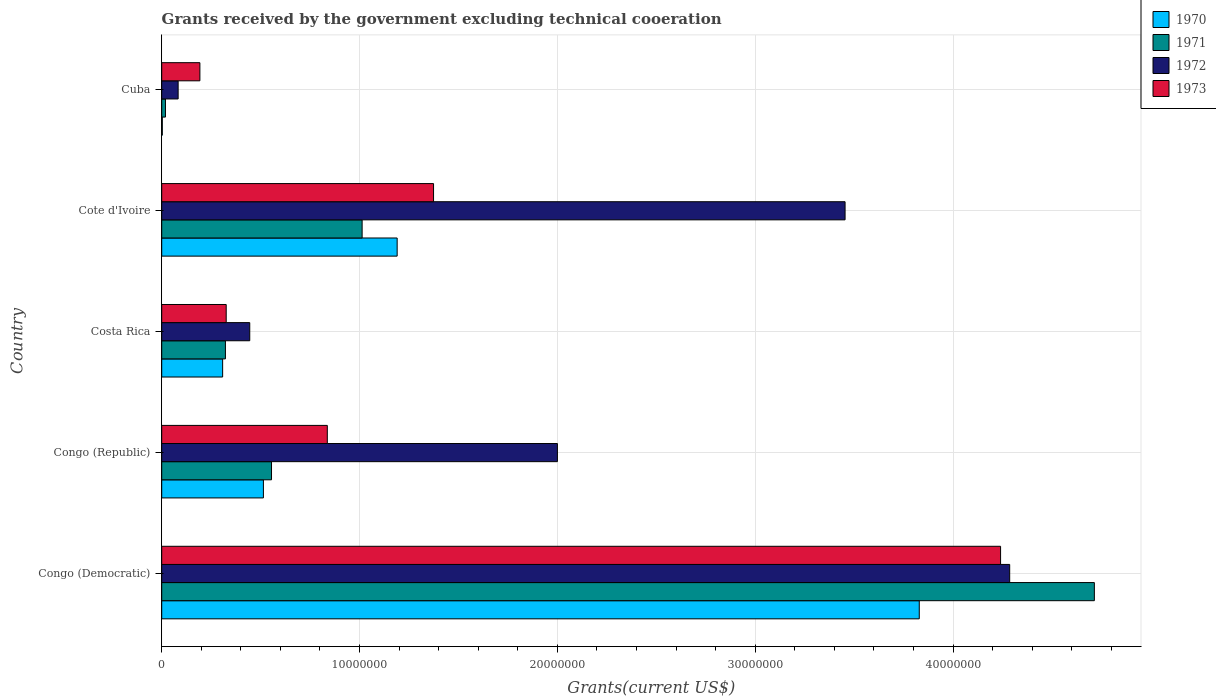How many different coloured bars are there?
Your answer should be very brief. 4. How many groups of bars are there?
Offer a very short reply. 5. How many bars are there on the 1st tick from the top?
Ensure brevity in your answer.  4. How many bars are there on the 3rd tick from the bottom?
Offer a very short reply. 4. What is the label of the 4th group of bars from the top?
Offer a very short reply. Congo (Republic). What is the total grants received by the government in 1972 in Costa Rica?
Keep it short and to the point. 4.45e+06. Across all countries, what is the maximum total grants received by the government in 1971?
Your answer should be very brief. 4.71e+07. In which country was the total grants received by the government in 1972 maximum?
Give a very brief answer. Congo (Democratic). In which country was the total grants received by the government in 1973 minimum?
Your answer should be very brief. Cuba. What is the total total grants received by the government in 1972 in the graph?
Give a very brief answer. 1.03e+08. What is the difference between the total grants received by the government in 1973 in Cote d'Ivoire and that in Cuba?
Offer a terse response. 1.18e+07. What is the difference between the total grants received by the government in 1970 in Congo (Republic) and the total grants received by the government in 1972 in Cuba?
Provide a succinct answer. 4.31e+06. What is the average total grants received by the government in 1971 per country?
Ensure brevity in your answer.  1.32e+07. What is the difference between the total grants received by the government in 1973 and total grants received by the government in 1971 in Congo (Democratic)?
Provide a short and direct response. -4.74e+06. What is the ratio of the total grants received by the government in 1973 in Congo (Democratic) to that in Congo (Republic)?
Your answer should be compact. 5.07. Is the difference between the total grants received by the government in 1973 in Costa Rica and Cote d'Ivoire greater than the difference between the total grants received by the government in 1971 in Costa Rica and Cote d'Ivoire?
Your answer should be very brief. No. What is the difference between the highest and the second highest total grants received by the government in 1973?
Give a very brief answer. 2.87e+07. What is the difference between the highest and the lowest total grants received by the government in 1970?
Ensure brevity in your answer.  3.83e+07. In how many countries, is the total grants received by the government in 1973 greater than the average total grants received by the government in 1973 taken over all countries?
Your answer should be very brief. 1. Is the sum of the total grants received by the government in 1973 in Congo (Democratic) and Congo (Republic) greater than the maximum total grants received by the government in 1972 across all countries?
Your answer should be compact. Yes. Is it the case that in every country, the sum of the total grants received by the government in 1972 and total grants received by the government in 1973 is greater than the sum of total grants received by the government in 1970 and total grants received by the government in 1971?
Make the answer very short. No. What does the 2nd bar from the top in Cote d'Ivoire represents?
Ensure brevity in your answer.  1972. What does the 1st bar from the bottom in Congo (Democratic) represents?
Ensure brevity in your answer.  1970. Are all the bars in the graph horizontal?
Provide a succinct answer. Yes. What is the difference between two consecutive major ticks on the X-axis?
Make the answer very short. 1.00e+07. Does the graph contain grids?
Make the answer very short. Yes. How are the legend labels stacked?
Offer a terse response. Vertical. What is the title of the graph?
Keep it short and to the point. Grants received by the government excluding technical cooeration. What is the label or title of the X-axis?
Keep it short and to the point. Grants(current US$). What is the Grants(current US$) in 1970 in Congo (Democratic)?
Provide a succinct answer. 3.83e+07. What is the Grants(current US$) in 1971 in Congo (Democratic)?
Give a very brief answer. 4.71e+07. What is the Grants(current US$) of 1972 in Congo (Democratic)?
Provide a succinct answer. 4.29e+07. What is the Grants(current US$) in 1973 in Congo (Democratic)?
Provide a succinct answer. 4.24e+07. What is the Grants(current US$) of 1970 in Congo (Republic)?
Give a very brief answer. 5.14e+06. What is the Grants(current US$) of 1971 in Congo (Republic)?
Your answer should be compact. 5.55e+06. What is the Grants(current US$) of 1972 in Congo (Republic)?
Give a very brief answer. 2.00e+07. What is the Grants(current US$) in 1973 in Congo (Republic)?
Offer a terse response. 8.37e+06. What is the Grants(current US$) of 1970 in Costa Rica?
Offer a terse response. 3.08e+06. What is the Grants(current US$) in 1971 in Costa Rica?
Make the answer very short. 3.22e+06. What is the Grants(current US$) of 1972 in Costa Rica?
Make the answer very short. 4.45e+06. What is the Grants(current US$) in 1973 in Costa Rica?
Make the answer very short. 3.26e+06. What is the Grants(current US$) of 1970 in Cote d'Ivoire?
Keep it short and to the point. 1.19e+07. What is the Grants(current US$) in 1971 in Cote d'Ivoire?
Provide a succinct answer. 1.01e+07. What is the Grants(current US$) of 1972 in Cote d'Ivoire?
Ensure brevity in your answer.  3.45e+07. What is the Grants(current US$) in 1973 in Cote d'Ivoire?
Keep it short and to the point. 1.37e+07. What is the Grants(current US$) of 1971 in Cuba?
Your response must be concise. 1.90e+05. What is the Grants(current US$) of 1972 in Cuba?
Keep it short and to the point. 8.30e+05. What is the Grants(current US$) of 1973 in Cuba?
Keep it short and to the point. 1.93e+06. Across all countries, what is the maximum Grants(current US$) in 1970?
Your answer should be compact. 3.83e+07. Across all countries, what is the maximum Grants(current US$) of 1971?
Keep it short and to the point. 4.71e+07. Across all countries, what is the maximum Grants(current US$) in 1972?
Your response must be concise. 4.29e+07. Across all countries, what is the maximum Grants(current US$) in 1973?
Provide a short and direct response. 4.24e+07. Across all countries, what is the minimum Grants(current US$) in 1972?
Your answer should be compact. 8.30e+05. Across all countries, what is the minimum Grants(current US$) in 1973?
Ensure brevity in your answer.  1.93e+06. What is the total Grants(current US$) in 1970 in the graph?
Your response must be concise. 5.84e+07. What is the total Grants(current US$) of 1971 in the graph?
Offer a terse response. 6.62e+07. What is the total Grants(current US$) in 1972 in the graph?
Your answer should be very brief. 1.03e+08. What is the total Grants(current US$) in 1973 in the graph?
Offer a terse response. 6.97e+07. What is the difference between the Grants(current US$) in 1970 in Congo (Democratic) and that in Congo (Republic)?
Your answer should be compact. 3.32e+07. What is the difference between the Grants(current US$) in 1971 in Congo (Democratic) and that in Congo (Republic)?
Give a very brief answer. 4.16e+07. What is the difference between the Grants(current US$) in 1972 in Congo (Democratic) and that in Congo (Republic)?
Keep it short and to the point. 2.29e+07. What is the difference between the Grants(current US$) of 1973 in Congo (Democratic) and that in Congo (Republic)?
Your response must be concise. 3.40e+07. What is the difference between the Grants(current US$) of 1970 in Congo (Democratic) and that in Costa Rica?
Offer a very short reply. 3.52e+07. What is the difference between the Grants(current US$) in 1971 in Congo (Democratic) and that in Costa Rica?
Offer a very short reply. 4.39e+07. What is the difference between the Grants(current US$) of 1972 in Congo (Democratic) and that in Costa Rica?
Make the answer very short. 3.84e+07. What is the difference between the Grants(current US$) of 1973 in Congo (Democratic) and that in Costa Rica?
Ensure brevity in your answer.  3.91e+07. What is the difference between the Grants(current US$) in 1970 in Congo (Democratic) and that in Cote d'Ivoire?
Provide a succinct answer. 2.64e+07. What is the difference between the Grants(current US$) of 1971 in Congo (Democratic) and that in Cote d'Ivoire?
Keep it short and to the point. 3.70e+07. What is the difference between the Grants(current US$) of 1972 in Congo (Democratic) and that in Cote d'Ivoire?
Offer a terse response. 8.32e+06. What is the difference between the Grants(current US$) of 1973 in Congo (Democratic) and that in Cote d'Ivoire?
Provide a short and direct response. 2.87e+07. What is the difference between the Grants(current US$) in 1970 in Congo (Democratic) and that in Cuba?
Keep it short and to the point. 3.83e+07. What is the difference between the Grants(current US$) in 1971 in Congo (Democratic) and that in Cuba?
Offer a very short reply. 4.70e+07. What is the difference between the Grants(current US$) in 1972 in Congo (Democratic) and that in Cuba?
Your answer should be very brief. 4.20e+07. What is the difference between the Grants(current US$) of 1973 in Congo (Democratic) and that in Cuba?
Your response must be concise. 4.05e+07. What is the difference between the Grants(current US$) in 1970 in Congo (Republic) and that in Costa Rica?
Offer a very short reply. 2.06e+06. What is the difference between the Grants(current US$) of 1971 in Congo (Republic) and that in Costa Rica?
Provide a succinct answer. 2.33e+06. What is the difference between the Grants(current US$) of 1972 in Congo (Republic) and that in Costa Rica?
Your response must be concise. 1.56e+07. What is the difference between the Grants(current US$) in 1973 in Congo (Republic) and that in Costa Rica?
Provide a succinct answer. 5.11e+06. What is the difference between the Grants(current US$) of 1970 in Congo (Republic) and that in Cote d'Ivoire?
Offer a terse response. -6.76e+06. What is the difference between the Grants(current US$) of 1971 in Congo (Republic) and that in Cote d'Ivoire?
Provide a succinct answer. -4.58e+06. What is the difference between the Grants(current US$) of 1972 in Congo (Republic) and that in Cote d'Ivoire?
Your response must be concise. -1.45e+07. What is the difference between the Grants(current US$) in 1973 in Congo (Republic) and that in Cote d'Ivoire?
Keep it short and to the point. -5.37e+06. What is the difference between the Grants(current US$) in 1970 in Congo (Republic) and that in Cuba?
Offer a very short reply. 5.11e+06. What is the difference between the Grants(current US$) in 1971 in Congo (Republic) and that in Cuba?
Make the answer very short. 5.36e+06. What is the difference between the Grants(current US$) in 1972 in Congo (Republic) and that in Cuba?
Ensure brevity in your answer.  1.92e+07. What is the difference between the Grants(current US$) of 1973 in Congo (Republic) and that in Cuba?
Make the answer very short. 6.44e+06. What is the difference between the Grants(current US$) in 1970 in Costa Rica and that in Cote d'Ivoire?
Provide a short and direct response. -8.82e+06. What is the difference between the Grants(current US$) of 1971 in Costa Rica and that in Cote d'Ivoire?
Offer a very short reply. -6.91e+06. What is the difference between the Grants(current US$) in 1972 in Costa Rica and that in Cote d'Ivoire?
Give a very brief answer. -3.01e+07. What is the difference between the Grants(current US$) of 1973 in Costa Rica and that in Cote d'Ivoire?
Your answer should be very brief. -1.05e+07. What is the difference between the Grants(current US$) in 1970 in Costa Rica and that in Cuba?
Provide a short and direct response. 3.05e+06. What is the difference between the Grants(current US$) in 1971 in Costa Rica and that in Cuba?
Keep it short and to the point. 3.03e+06. What is the difference between the Grants(current US$) of 1972 in Costa Rica and that in Cuba?
Make the answer very short. 3.62e+06. What is the difference between the Grants(current US$) in 1973 in Costa Rica and that in Cuba?
Make the answer very short. 1.33e+06. What is the difference between the Grants(current US$) of 1970 in Cote d'Ivoire and that in Cuba?
Provide a succinct answer. 1.19e+07. What is the difference between the Grants(current US$) of 1971 in Cote d'Ivoire and that in Cuba?
Provide a short and direct response. 9.94e+06. What is the difference between the Grants(current US$) of 1972 in Cote d'Ivoire and that in Cuba?
Your response must be concise. 3.37e+07. What is the difference between the Grants(current US$) of 1973 in Cote d'Ivoire and that in Cuba?
Ensure brevity in your answer.  1.18e+07. What is the difference between the Grants(current US$) of 1970 in Congo (Democratic) and the Grants(current US$) of 1971 in Congo (Republic)?
Provide a short and direct response. 3.27e+07. What is the difference between the Grants(current US$) in 1970 in Congo (Democratic) and the Grants(current US$) in 1972 in Congo (Republic)?
Offer a very short reply. 1.83e+07. What is the difference between the Grants(current US$) in 1970 in Congo (Democratic) and the Grants(current US$) in 1973 in Congo (Republic)?
Give a very brief answer. 2.99e+07. What is the difference between the Grants(current US$) in 1971 in Congo (Democratic) and the Grants(current US$) in 1972 in Congo (Republic)?
Provide a succinct answer. 2.71e+07. What is the difference between the Grants(current US$) of 1971 in Congo (Democratic) and the Grants(current US$) of 1973 in Congo (Republic)?
Your response must be concise. 3.88e+07. What is the difference between the Grants(current US$) of 1972 in Congo (Democratic) and the Grants(current US$) of 1973 in Congo (Republic)?
Ensure brevity in your answer.  3.45e+07. What is the difference between the Grants(current US$) of 1970 in Congo (Democratic) and the Grants(current US$) of 1971 in Costa Rica?
Ensure brevity in your answer.  3.51e+07. What is the difference between the Grants(current US$) of 1970 in Congo (Democratic) and the Grants(current US$) of 1972 in Costa Rica?
Offer a terse response. 3.38e+07. What is the difference between the Grants(current US$) of 1970 in Congo (Democratic) and the Grants(current US$) of 1973 in Costa Rica?
Provide a succinct answer. 3.50e+07. What is the difference between the Grants(current US$) of 1971 in Congo (Democratic) and the Grants(current US$) of 1972 in Costa Rica?
Your answer should be very brief. 4.27e+07. What is the difference between the Grants(current US$) of 1971 in Congo (Democratic) and the Grants(current US$) of 1973 in Costa Rica?
Your answer should be compact. 4.39e+07. What is the difference between the Grants(current US$) of 1972 in Congo (Democratic) and the Grants(current US$) of 1973 in Costa Rica?
Your answer should be very brief. 3.96e+07. What is the difference between the Grants(current US$) of 1970 in Congo (Democratic) and the Grants(current US$) of 1971 in Cote d'Ivoire?
Provide a succinct answer. 2.82e+07. What is the difference between the Grants(current US$) of 1970 in Congo (Democratic) and the Grants(current US$) of 1972 in Cote d'Ivoire?
Ensure brevity in your answer.  3.75e+06. What is the difference between the Grants(current US$) in 1970 in Congo (Democratic) and the Grants(current US$) in 1973 in Cote d'Ivoire?
Your answer should be very brief. 2.46e+07. What is the difference between the Grants(current US$) of 1971 in Congo (Democratic) and the Grants(current US$) of 1972 in Cote d'Ivoire?
Your answer should be compact. 1.26e+07. What is the difference between the Grants(current US$) in 1971 in Congo (Democratic) and the Grants(current US$) in 1973 in Cote d'Ivoire?
Provide a short and direct response. 3.34e+07. What is the difference between the Grants(current US$) in 1972 in Congo (Democratic) and the Grants(current US$) in 1973 in Cote d'Ivoire?
Provide a succinct answer. 2.91e+07. What is the difference between the Grants(current US$) in 1970 in Congo (Democratic) and the Grants(current US$) in 1971 in Cuba?
Make the answer very short. 3.81e+07. What is the difference between the Grants(current US$) of 1970 in Congo (Democratic) and the Grants(current US$) of 1972 in Cuba?
Offer a terse response. 3.75e+07. What is the difference between the Grants(current US$) in 1970 in Congo (Democratic) and the Grants(current US$) in 1973 in Cuba?
Your response must be concise. 3.64e+07. What is the difference between the Grants(current US$) in 1971 in Congo (Democratic) and the Grants(current US$) in 1972 in Cuba?
Ensure brevity in your answer.  4.63e+07. What is the difference between the Grants(current US$) in 1971 in Congo (Democratic) and the Grants(current US$) in 1973 in Cuba?
Offer a very short reply. 4.52e+07. What is the difference between the Grants(current US$) in 1972 in Congo (Democratic) and the Grants(current US$) in 1973 in Cuba?
Provide a short and direct response. 4.09e+07. What is the difference between the Grants(current US$) in 1970 in Congo (Republic) and the Grants(current US$) in 1971 in Costa Rica?
Offer a terse response. 1.92e+06. What is the difference between the Grants(current US$) of 1970 in Congo (Republic) and the Grants(current US$) of 1972 in Costa Rica?
Your response must be concise. 6.90e+05. What is the difference between the Grants(current US$) in 1970 in Congo (Republic) and the Grants(current US$) in 1973 in Costa Rica?
Your answer should be compact. 1.88e+06. What is the difference between the Grants(current US$) of 1971 in Congo (Republic) and the Grants(current US$) of 1972 in Costa Rica?
Keep it short and to the point. 1.10e+06. What is the difference between the Grants(current US$) in 1971 in Congo (Republic) and the Grants(current US$) in 1973 in Costa Rica?
Your answer should be compact. 2.29e+06. What is the difference between the Grants(current US$) in 1972 in Congo (Republic) and the Grants(current US$) in 1973 in Costa Rica?
Offer a terse response. 1.67e+07. What is the difference between the Grants(current US$) of 1970 in Congo (Republic) and the Grants(current US$) of 1971 in Cote d'Ivoire?
Your response must be concise. -4.99e+06. What is the difference between the Grants(current US$) in 1970 in Congo (Republic) and the Grants(current US$) in 1972 in Cote d'Ivoire?
Provide a succinct answer. -2.94e+07. What is the difference between the Grants(current US$) in 1970 in Congo (Republic) and the Grants(current US$) in 1973 in Cote d'Ivoire?
Provide a succinct answer. -8.60e+06. What is the difference between the Grants(current US$) in 1971 in Congo (Republic) and the Grants(current US$) in 1972 in Cote d'Ivoire?
Your answer should be compact. -2.90e+07. What is the difference between the Grants(current US$) of 1971 in Congo (Republic) and the Grants(current US$) of 1973 in Cote d'Ivoire?
Ensure brevity in your answer.  -8.19e+06. What is the difference between the Grants(current US$) of 1972 in Congo (Republic) and the Grants(current US$) of 1973 in Cote d'Ivoire?
Your answer should be very brief. 6.26e+06. What is the difference between the Grants(current US$) in 1970 in Congo (Republic) and the Grants(current US$) in 1971 in Cuba?
Your answer should be compact. 4.95e+06. What is the difference between the Grants(current US$) of 1970 in Congo (Republic) and the Grants(current US$) of 1972 in Cuba?
Offer a terse response. 4.31e+06. What is the difference between the Grants(current US$) of 1970 in Congo (Republic) and the Grants(current US$) of 1973 in Cuba?
Ensure brevity in your answer.  3.21e+06. What is the difference between the Grants(current US$) of 1971 in Congo (Republic) and the Grants(current US$) of 1972 in Cuba?
Offer a terse response. 4.72e+06. What is the difference between the Grants(current US$) of 1971 in Congo (Republic) and the Grants(current US$) of 1973 in Cuba?
Your response must be concise. 3.62e+06. What is the difference between the Grants(current US$) of 1972 in Congo (Republic) and the Grants(current US$) of 1973 in Cuba?
Make the answer very short. 1.81e+07. What is the difference between the Grants(current US$) of 1970 in Costa Rica and the Grants(current US$) of 1971 in Cote d'Ivoire?
Ensure brevity in your answer.  -7.05e+06. What is the difference between the Grants(current US$) of 1970 in Costa Rica and the Grants(current US$) of 1972 in Cote d'Ivoire?
Give a very brief answer. -3.15e+07. What is the difference between the Grants(current US$) in 1970 in Costa Rica and the Grants(current US$) in 1973 in Cote d'Ivoire?
Ensure brevity in your answer.  -1.07e+07. What is the difference between the Grants(current US$) of 1971 in Costa Rica and the Grants(current US$) of 1972 in Cote d'Ivoire?
Give a very brief answer. -3.13e+07. What is the difference between the Grants(current US$) in 1971 in Costa Rica and the Grants(current US$) in 1973 in Cote d'Ivoire?
Offer a very short reply. -1.05e+07. What is the difference between the Grants(current US$) of 1972 in Costa Rica and the Grants(current US$) of 1973 in Cote d'Ivoire?
Provide a succinct answer. -9.29e+06. What is the difference between the Grants(current US$) in 1970 in Costa Rica and the Grants(current US$) in 1971 in Cuba?
Give a very brief answer. 2.89e+06. What is the difference between the Grants(current US$) of 1970 in Costa Rica and the Grants(current US$) of 1972 in Cuba?
Provide a short and direct response. 2.25e+06. What is the difference between the Grants(current US$) in 1970 in Costa Rica and the Grants(current US$) in 1973 in Cuba?
Make the answer very short. 1.15e+06. What is the difference between the Grants(current US$) in 1971 in Costa Rica and the Grants(current US$) in 1972 in Cuba?
Ensure brevity in your answer.  2.39e+06. What is the difference between the Grants(current US$) of 1971 in Costa Rica and the Grants(current US$) of 1973 in Cuba?
Your response must be concise. 1.29e+06. What is the difference between the Grants(current US$) in 1972 in Costa Rica and the Grants(current US$) in 1973 in Cuba?
Your answer should be very brief. 2.52e+06. What is the difference between the Grants(current US$) in 1970 in Cote d'Ivoire and the Grants(current US$) in 1971 in Cuba?
Offer a terse response. 1.17e+07. What is the difference between the Grants(current US$) of 1970 in Cote d'Ivoire and the Grants(current US$) of 1972 in Cuba?
Give a very brief answer. 1.11e+07. What is the difference between the Grants(current US$) of 1970 in Cote d'Ivoire and the Grants(current US$) of 1973 in Cuba?
Make the answer very short. 9.97e+06. What is the difference between the Grants(current US$) of 1971 in Cote d'Ivoire and the Grants(current US$) of 1972 in Cuba?
Ensure brevity in your answer.  9.30e+06. What is the difference between the Grants(current US$) of 1971 in Cote d'Ivoire and the Grants(current US$) of 1973 in Cuba?
Offer a terse response. 8.20e+06. What is the difference between the Grants(current US$) in 1972 in Cote d'Ivoire and the Grants(current US$) in 1973 in Cuba?
Offer a terse response. 3.26e+07. What is the average Grants(current US$) in 1970 per country?
Provide a succinct answer. 1.17e+07. What is the average Grants(current US$) in 1971 per country?
Your answer should be compact. 1.32e+07. What is the average Grants(current US$) of 1972 per country?
Provide a succinct answer. 2.05e+07. What is the average Grants(current US$) in 1973 per country?
Keep it short and to the point. 1.39e+07. What is the difference between the Grants(current US$) in 1970 and Grants(current US$) in 1971 in Congo (Democratic)?
Your answer should be compact. -8.85e+06. What is the difference between the Grants(current US$) in 1970 and Grants(current US$) in 1972 in Congo (Democratic)?
Ensure brevity in your answer.  -4.57e+06. What is the difference between the Grants(current US$) in 1970 and Grants(current US$) in 1973 in Congo (Democratic)?
Keep it short and to the point. -4.11e+06. What is the difference between the Grants(current US$) of 1971 and Grants(current US$) of 1972 in Congo (Democratic)?
Offer a terse response. 4.28e+06. What is the difference between the Grants(current US$) of 1971 and Grants(current US$) of 1973 in Congo (Democratic)?
Offer a terse response. 4.74e+06. What is the difference between the Grants(current US$) in 1970 and Grants(current US$) in 1971 in Congo (Republic)?
Ensure brevity in your answer.  -4.10e+05. What is the difference between the Grants(current US$) in 1970 and Grants(current US$) in 1972 in Congo (Republic)?
Your response must be concise. -1.49e+07. What is the difference between the Grants(current US$) in 1970 and Grants(current US$) in 1973 in Congo (Republic)?
Your answer should be compact. -3.23e+06. What is the difference between the Grants(current US$) in 1971 and Grants(current US$) in 1972 in Congo (Republic)?
Provide a succinct answer. -1.44e+07. What is the difference between the Grants(current US$) in 1971 and Grants(current US$) in 1973 in Congo (Republic)?
Keep it short and to the point. -2.82e+06. What is the difference between the Grants(current US$) of 1972 and Grants(current US$) of 1973 in Congo (Republic)?
Provide a short and direct response. 1.16e+07. What is the difference between the Grants(current US$) of 1970 and Grants(current US$) of 1971 in Costa Rica?
Your answer should be very brief. -1.40e+05. What is the difference between the Grants(current US$) of 1970 and Grants(current US$) of 1972 in Costa Rica?
Your answer should be very brief. -1.37e+06. What is the difference between the Grants(current US$) of 1971 and Grants(current US$) of 1972 in Costa Rica?
Provide a short and direct response. -1.23e+06. What is the difference between the Grants(current US$) in 1972 and Grants(current US$) in 1973 in Costa Rica?
Offer a terse response. 1.19e+06. What is the difference between the Grants(current US$) in 1970 and Grants(current US$) in 1971 in Cote d'Ivoire?
Your response must be concise. 1.77e+06. What is the difference between the Grants(current US$) in 1970 and Grants(current US$) in 1972 in Cote d'Ivoire?
Offer a very short reply. -2.26e+07. What is the difference between the Grants(current US$) in 1970 and Grants(current US$) in 1973 in Cote d'Ivoire?
Make the answer very short. -1.84e+06. What is the difference between the Grants(current US$) in 1971 and Grants(current US$) in 1972 in Cote d'Ivoire?
Give a very brief answer. -2.44e+07. What is the difference between the Grants(current US$) in 1971 and Grants(current US$) in 1973 in Cote d'Ivoire?
Your answer should be very brief. -3.61e+06. What is the difference between the Grants(current US$) of 1972 and Grants(current US$) of 1973 in Cote d'Ivoire?
Provide a succinct answer. 2.08e+07. What is the difference between the Grants(current US$) of 1970 and Grants(current US$) of 1971 in Cuba?
Keep it short and to the point. -1.60e+05. What is the difference between the Grants(current US$) in 1970 and Grants(current US$) in 1972 in Cuba?
Give a very brief answer. -8.00e+05. What is the difference between the Grants(current US$) of 1970 and Grants(current US$) of 1973 in Cuba?
Your answer should be very brief. -1.90e+06. What is the difference between the Grants(current US$) of 1971 and Grants(current US$) of 1972 in Cuba?
Your answer should be very brief. -6.40e+05. What is the difference between the Grants(current US$) in 1971 and Grants(current US$) in 1973 in Cuba?
Give a very brief answer. -1.74e+06. What is the difference between the Grants(current US$) of 1972 and Grants(current US$) of 1973 in Cuba?
Make the answer very short. -1.10e+06. What is the ratio of the Grants(current US$) of 1970 in Congo (Democratic) to that in Congo (Republic)?
Provide a succinct answer. 7.45. What is the ratio of the Grants(current US$) of 1971 in Congo (Democratic) to that in Congo (Republic)?
Offer a very short reply. 8.49. What is the ratio of the Grants(current US$) in 1972 in Congo (Democratic) to that in Congo (Republic)?
Keep it short and to the point. 2.14. What is the ratio of the Grants(current US$) in 1973 in Congo (Democratic) to that in Congo (Republic)?
Keep it short and to the point. 5.07. What is the ratio of the Grants(current US$) of 1970 in Congo (Democratic) to that in Costa Rica?
Ensure brevity in your answer.  12.43. What is the ratio of the Grants(current US$) in 1971 in Congo (Democratic) to that in Costa Rica?
Your response must be concise. 14.64. What is the ratio of the Grants(current US$) of 1972 in Congo (Democratic) to that in Costa Rica?
Your response must be concise. 9.63. What is the ratio of the Grants(current US$) in 1973 in Congo (Democratic) to that in Costa Rica?
Provide a succinct answer. 13.01. What is the ratio of the Grants(current US$) of 1970 in Congo (Democratic) to that in Cote d'Ivoire?
Your answer should be very brief. 3.22. What is the ratio of the Grants(current US$) of 1971 in Congo (Democratic) to that in Cote d'Ivoire?
Make the answer very short. 4.65. What is the ratio of the Grants(current US$) in 1972 in Congo (Democratic) to that in Cote d'Ivoire?
Keep it short and to the point. 1.24. What is the ratio of the Grants(current US$) of 1973 in Congo (Democratic) to that in Cote d'Ivoire?
Keep it short and to the point. 3.09. What is the ratio of the Grants(current US$) of 1970 in Congo (Democratic) to that in Cuba?
Your answer should be very brief. 1276.33. What is the ratio of the Grants(current US$) of 1971 in Congo (Democratic) to that in Cuba?
Ensure brevity in your answer.  248.11. What is the ratio of the Grants(current US$) in 1972 in Congo (Democratic) to that in Cuba?
Keep it short and to the point. 51.64. What is the ratio of the Grants(current US$) of 1973 in Congo (Democratic) to that in Cuba?
Your answer should be very brief. 21.97. What is the ratio of the Grants(current US$) in 1970 in Congo (Republic) to that in Costa Rica?
Provide a succinct answer. 1.67. What is the ratio of the Grants(current US$) of 1971 in Congo (Republic) to that in Costa Rica?
Your answer should be compact. 1.72. What is the ratio of the Grants(current US$) in 1972 in Congo (Republic) to that in Costa Rica?
Offer a terse response. 4.49. What is the ratio of the Grants(current US$) in 1973 in Congo (Republic) to that in Costa Rica?
Offer a terse response. 2.57. What is the ratio of the Grants(current US$) of 1970 in Congo (Republic) to that in Cote d'Ivoire?
Ensure brevity in your answer.  0.43. What is the ratio of the Grants(current US$) in 1971 in Congo (Republic) to that in Cote d'Ivoire?
Ensure brevity in your answer.  0.55. What is the ratio of the Grants(current US$) in 1972 in Congo (Republic) to that in Cote d'Ivoire?
Give a very brief answer. 0.58. What is the ratio of the Grants(current US$) of 1973 in Congo (Republic) to that in Cote d'Ivoire?
Your answer should be very brief. 0.61. What is the ratio of the Grants(current US$) of 1970 in Congo (Republic) to that in Cuba?
Keep it short and to the point. 171.33. What is the ratio of the Grants(current US$) in 1971 in Congo (Republic) to that in Cuba?
Your response must be concise. 29.21. What is the ratio of the Grants(current US$) in 1972 in Congo (Republic) to that in Cuba?
Offer a terse response. 24.1. What is the ratio of the Grants(current US$) of 1973 in Congo (Republic) to that in Cuba?
Ensure brevity in your answer.  4.34. What is the ratio of the Grants(current US$) in 1970 in Costa Rica to that in Cote d'Ivoire?
Ensure brevity in your answer.  0.26. What is the ratio of the Grants(current US$) of 1971 in Costa Rica to that in Cote d'Ivoire?
Make the answer very short. 0.32. What is the ratio of the Grants(current US$) of 1972 in Costa Rica to that in Cote d'Ivoire?
Offer a very short reply. 0.13. What is the ratio of the Grants(current US$) in 1973 in Costa Rica to that in Cote d'Ivoire?
Make the answer very short. 0.24. What is the ratio of the Grants(current US$) of 1970 in Costa Rica to that in Cuba?
Offer a very short reply. 102.67. What is the ratio of the Grants(current US$) of 1971 in Costa Rica to that in Cuba?
Make the answer very short. 16.95. What is the ratio of the Grants(current US$) in 1972 in Costa Rica to that in Cuba?
Your response must be concise. 5.36. What is the ratio of the Grants(current US$) in 1973 in Costa Rica to that in Cuba?
Your response must be concise. 1.69. What is the ratio of the Grants(current US$) in 1970 in Cote d'Ivoire to that in Cuba?
Keep it short and to the point. 396.67. What is the ratio of the Grants(current US$) in 1971 in Cote d'Ivoire to that in Cuba?
Your answer should be compact. 53.32. What is the ratio of the Grants(current US$) in 1972 in Cote d'Ivoire to that in Cuba?
Make the answer very short. 41.61. What is the ratio of the Grants(current US$) in 1973 in Cote d'Ivoire to that in Cuba?
Make the answer very short. 7.12. What is the difference between the highest and the second highest Grants(current US$) in 1970?
Make the answer very short. 2.64e+07. What is the difference between the highest and the second highest Grants(current US$) in 1971?
Your answer should be very brief. 3.70e+07. What is the difference between the highest and the second highest Grants(current US$) in 1972?
Keep it short and to the point. 8.32e+06. What is the difference between the highest and the second highest Grants(current US$) of 1973?
Your answer should be compact. 2.87e+07. What is the difference between the highest and the lowest Grants(current US$) of 1970?
Offer a terse response. 3.83e+07. What is the difference between the highest and the lowest Grants(current US$) of 1971?
Provide a short and direct response. 4.70e+07. What is the difference between the highest and the lowest Grants(current US$) of 1972?
Keep it short and to the point. 4.20e+07. What is the difference between the highest and the lowest Grants(current US$) of 1973?
Keep it short and to the point. 4.05e+07. 